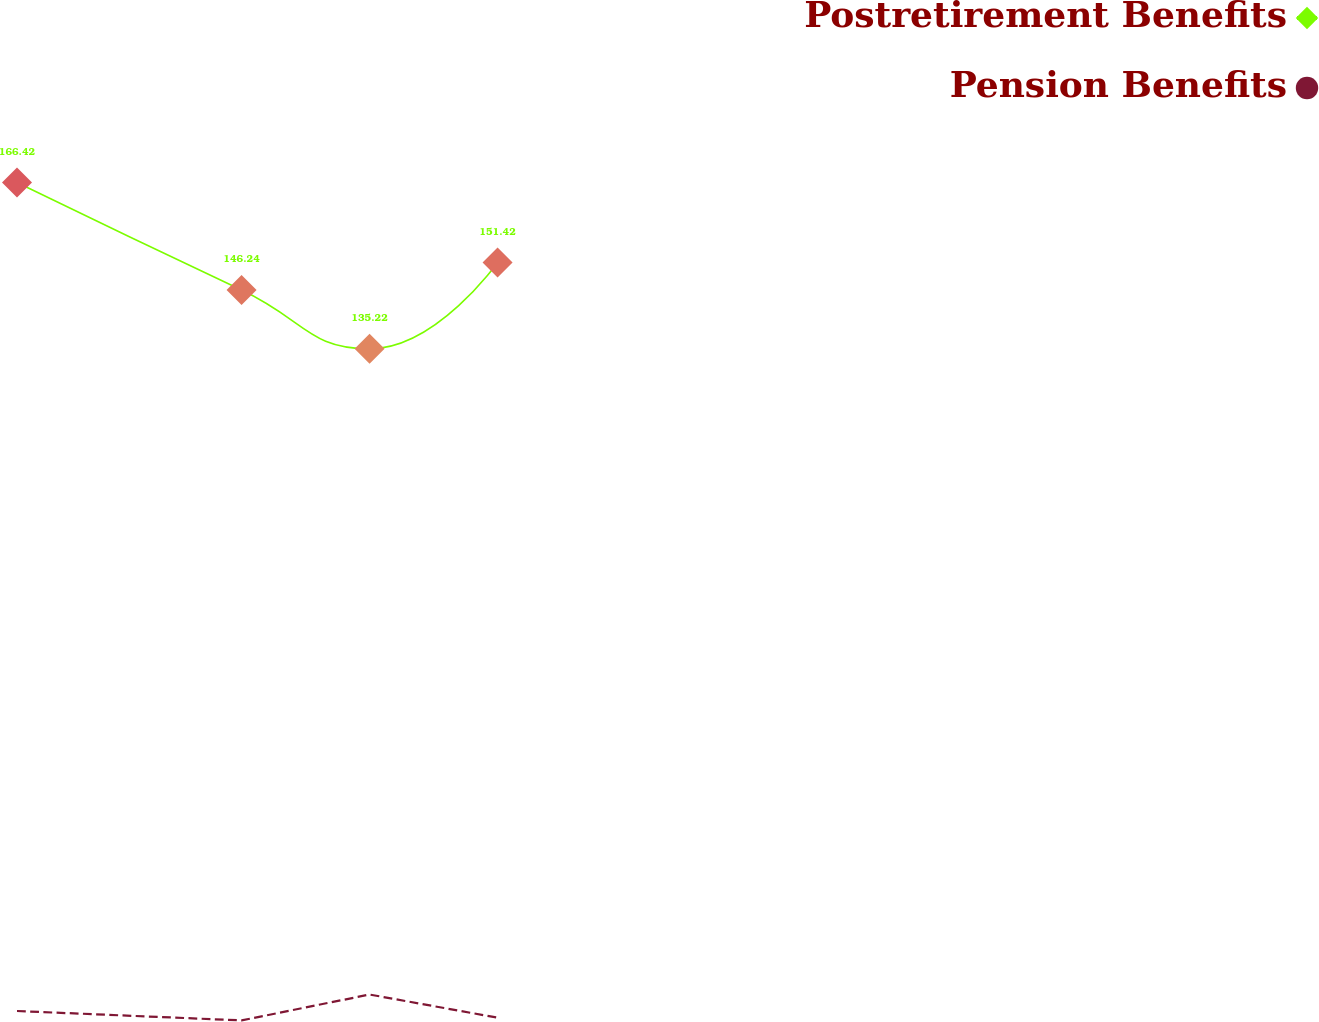Convert chart. <chart><loc_0><loc_0><loc_500><loc_500><line_chart><ecel><fcel>Postretirement Benefits<fcel>Pension Benefits<nl><fcel>1613.27<fcel>166.42<fcel>11.06<nl><fcel>1750.47<fcel>146.24<fcel>9.3<nl><fcel>1828.67<fcel>135.22<fcel>14.15<nl><fcel>1906.87<fcel>151.42<fcel>9.81<nl><fcel>2395.29<fcel>173.17<fcel>10.29<nl></chart> 